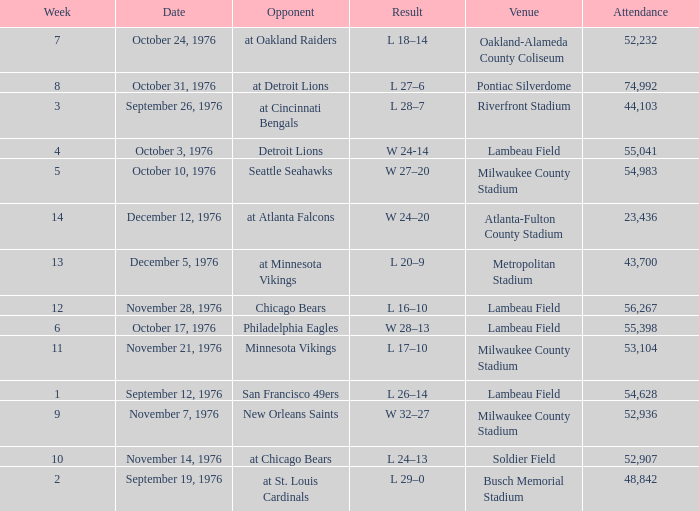What is the average attendance for the game on September 26, 1976? 44103.0. 